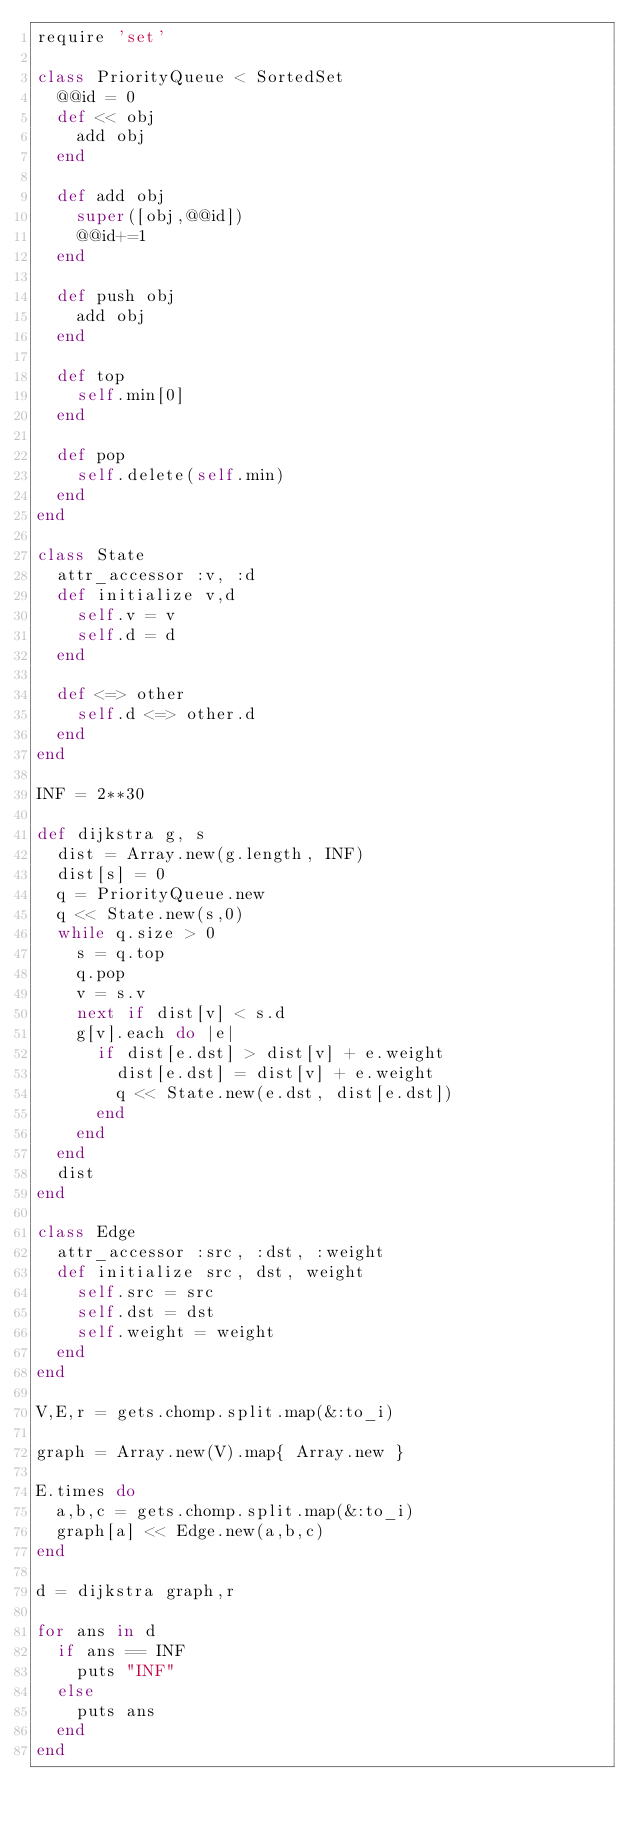<code> <loc_0><loc_0><loc_500><loc_500><_Ruby_>require 'set'

class PriorityQueue < SortedSet
  @@id = 0
  def << obj
    add obj
  end

  def add obj
    super([obj,@@id])
    @@id+=1
  end

  def push obj
    add obj
  end

  def top
    self.min[0]
  end

  def pop
    self.delete(self.min)
  end
end

class State
  attr_accessor :v, :d
  def initialize v,d
    self.v = v
    self.d = d
  end

  def <=> other
    self.d <=> other.d
  end
end

INF = 2**30

def dijkstra g, s
  dist = Array.new(g.length, INF)
  dist[s] = 0
  q = PriorityQueue.new
  q << State.new(s,0)
  while q.size > 0
    s = q.top
    q.pop
    v = s.v
    next if dist[v] < s.d
    g[v].each do |e|
      if dist[e.dst] > dist[v] + e.weight
        dist[e.dst] = dist[v] + e.weight
        q << State.new(e.dst, dist[e.dst])
      end
    end
  end
  dist
end

class Edge
  attr_accessor :src, :dst, :weight
  def initialize src, dst, weight
    self.src = src
    self.dst = dst
    self.weight = weight
  end
end

V,E,r = gets.chomp.split.map(&:to_i)

graph = Array.new(V).map{ Array.new }

E.times do
  a,b,c = gets.chomp.split.map(&:to_i)
  graph[a] << Edge.new(a,b,c)
end

d = dijkstra graph,r

for ans in d
  if ans == INF
    puts "INF"
  else
    puts ans
  end
end</code> 